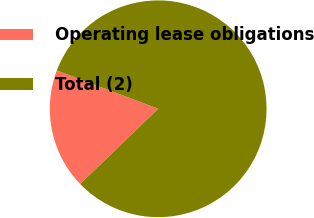<chart> <loc_0><loc_0><loc_500><loc_500><pie_chart><fcel>Operating lease obligations<fcel>Total (2)<nl><fcel>17.96%<fcel>82.04%<nl></chart> 